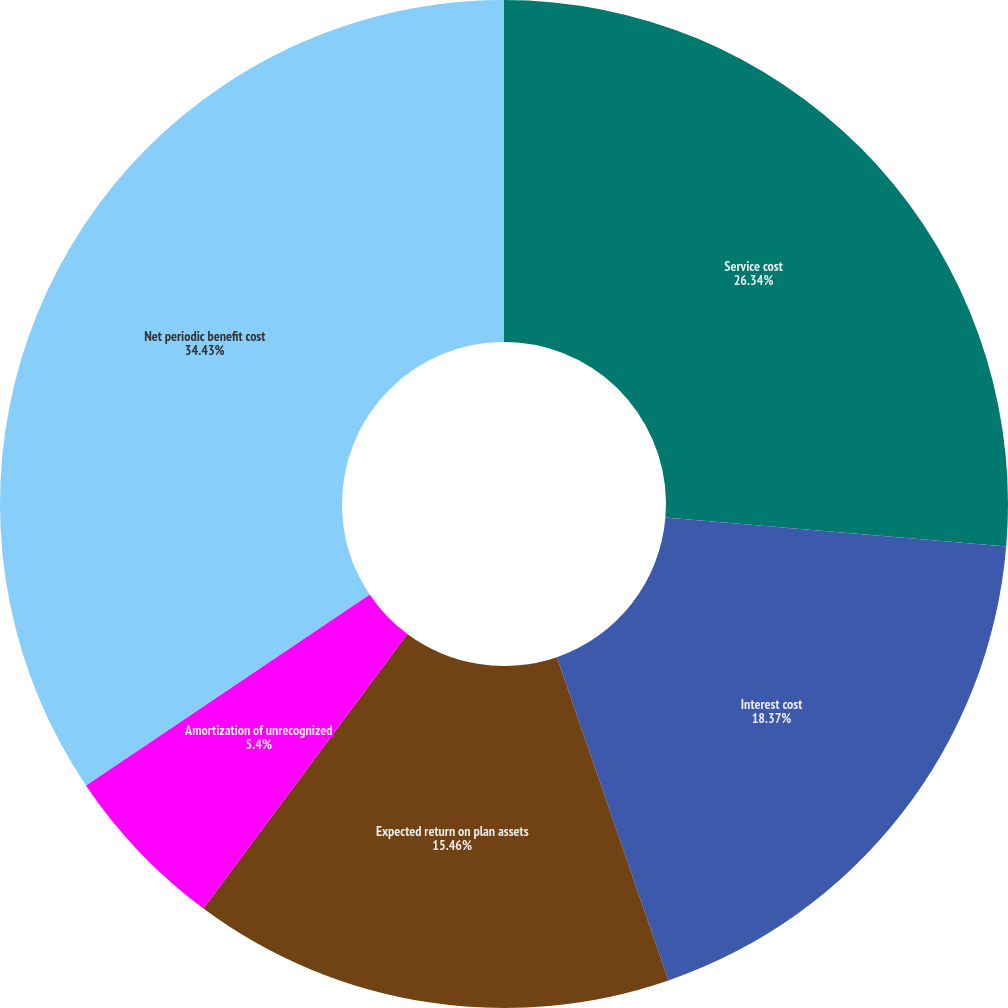Convert chart to OTSL. <chart><loc_0><loc_0><loc_500><loc_500><pie_chart><fcel>Service cost<fcel>Interest cost<fcel>Expected return on plan assets<fcel>Amortization of unrecognized<fcel>Net periodic benefit cost<nl><fcel>26.34%<fcel>18.37%<fcel>15.46%<fcel>5.4%<fcel>34.43%<nl></chart> 